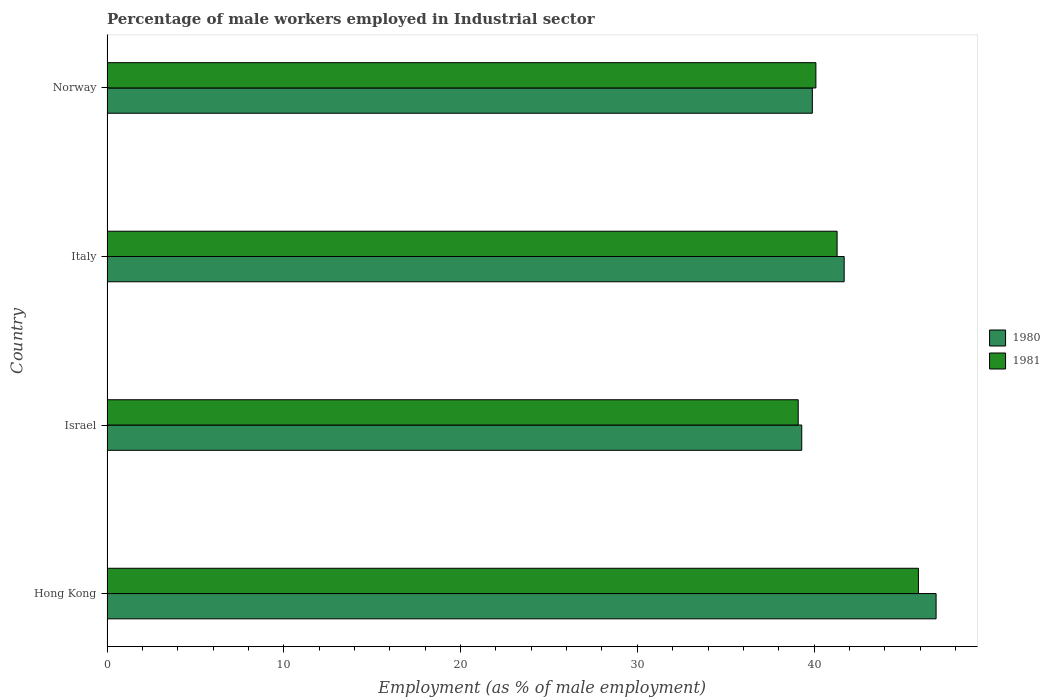How many bars are there on the 1st tick from the top?
Offer a terse response. 2. How many bars are there on the 3rd tick from the bottom?
Make the answer very short. 2. What is the percentage of male workers employed in Industrial sector in 1980 in Italy?
Give a very brief answer. 41.7. Across all countries, what is the maximum percentage of male workers employed in Industrial sector in 1980?
Offer a very short reply. 46.9. Across all countries, what is the minimum percentage of male workers employed in Industrial sector in 1981?
Provide a short and direct response. 39.1. In which country was the percentage of male workers employed in Industrial sector in 1981 maximum?
Keep it short and to the point. Hong Kong. What is the total percentage of male workers employed in Industrial sector in 1981 in the graph?
Provide a succinct answer. 166.4. What is the difference between the percentage of male workers employed in Industrial sector in 1980 in Hong Kong and that in Italy?
Keep it short and to the point. 5.2. What is the difference between the percentage of male workers employed in Industrial sector in 1981 in Israel and the percentage of male workers employed in Industrial sector in 1980 in Norway?
Your response must be concise. -0.8. What is the average percentage of male workers employed in Industrial sector in 1981 per country?
Provide a succinct answer. 41.6. What is the difference between the percentage of male workers employed in Industrial sector in 1981 and percentage of male workers employed in Industrial sector in 1980 in Norway?
Ensure brevity in your answer.  0.2. In how many countries, is the percentage of male workers employed in Industrial sector in 1980 greater than 24 %?
Keep it short and to the point. 4. What is the ratio of the percentage of male workers employed in Industrial sector in 1980 in Italy to that in Norway?
Give a very brief answer. 1.05. Is the percentage of male workers employed in Industrial sector in 1980 in Hong Kong less than that in Italy?
Your answer should be compact. No. Is the difference between the percentage of male workers employed in Industrial sector in 1981 in Italy and Norway greater than the difference between the percentage of male workers employed in Industrial sector in 1980 in Italy and Norway?
Keep it short and to the point. No. What is the difference between the highest and the second highest percentage of male workers employed in Industrial sector in 1980?
Provide a succinct answer. 5.2. What is the difference between the highest and the lowest percentage of male workers employed in Industrial sector in 1981?
Keep it short and to the point. 6.8. Is the sum of the percentage of male workers employed in Industrial sector in 1981 in Israel and Italy greater than the maximum percentage of male workers employed in Industrial sector in 1980 across all countries?
Provide a short and direct response. Yes. What does the 1st bar from the top in Italy represents?
Make the answer very short. 1981. How many bars are there?
Your answer should be compact. 8. How many countries are there in the graph?
Give a very brief answer. 4. What is the difference between two consecutive major ticks on the X-axis?
Make the answer very short. 10. Does the graph contain any zero values?
Keep it short and to the point. No. Does the graph contain grids?
Provide a succinct answer. No. Where does the legend appear in the graph?
Your answer should be compact. Center right. How are the legend labels stacked?
Offer a very short reply. Vertical. What is the title of the graph?
Your answer should be compact. Percentage of male workers employed in Industrial sector. What is the label or title of the X-axis?
Your answer should be compact. Employment (as % of male employment). What is the label or title of the Y-axis?
Offer a very short reply. Country. What is the Employment (as % of male employment) in 1980 in Hong Kong?
Keep it short and to the point. 46.9. What is the Employment (as % of male employment) of 1981 in Hong Kong?
Make the answer very short. 45.9. What is the Employment (as % of male employment) of 1980 in Israel?
Provide a succinct answer. 39.3. What is the Employment (as % of male employment) in 1981 in Israel?
Provide a succinct answer. 39.1. What is the Employment (as % of male employment) of 1980 in Italy?
Your answer should be very brief. 41.7. What is the Employment (as % of male employment) of 1981 in Italy?
Make the answer very short. 41.3. What is the Employment (as % of male employment) in 1980 in Norway?
Offer a very short reply. 39.9. What is the Employment (as % of male employment) of 1981 in Norway?
Your answer should be very brief. 40.1. Across all countries, what is the maximum Employment (as % of male employment) of 1980?
Provide a short and direct response. 46.9. Across all countries, what is the maximum Employment (as % of male employment) of 1981?
Your answer should be very brief. 45.9. Across all countries, what is the minimum Employment (as % of male employment) in 1980?
Keep it short and to the point. 39.3. Across all countries, what is the minimum Employment (as % of male employment) in 1981?
Ensure brevity in your answer.  39.1. What is the total Employment (as % of male employment) in 1980 in the graph?
Ensure brevity in your answer.  167.8. What is the total Employment (as % of male employment) of 1981 in the graph?
Provide a succinct answer. 166.4. What is the difference between the Employment (as % of male employment) of 1981 in Hong Kong and that in Italy?
Provide a succinct answer. 4.6. What is the difference between the Employment (as % of male employment) of 1981 in Hong Kong and that in Norway?
Make the answer very short. 5.8. What is the difference between the Employment (as % of male employment) of 1980 in Israel and that in Norway?
Provide a short and direct response. -0.6. What is the difference between the Employment (as % of male employment) in 1980 in Italy and that in Norway?
Your answer should be compact. 1.8. What is the difference between the Employment (as % of male employment) in 1980 in Hong Kong and the Employment (as % of male employment) in 1981 in Italy?
Offer a terse response. 5.6. What is the difference between the Employment (as % of male employment) in 1980 in Israel and the Employment (as % of male employment) in 1981 in Italy?
Provide a short and direct response. -2. What is the average Employment (as % of male employment) in 1980 per country?
Ensure brevity in your answer.  41.95. What is the average Employment (as % of male employment) of 1981 per country?
Give a very brief answer. 41.6. What is the difference between the Employment (as % of male employment) in 1980 and Employment (as % of male employment) in 1981 in Hong Kong?
Your answer should be very brief. 1. What is the difference between the Employment (as % of male employment) of 1980 and Employment (as % of male employment) of 1981 in Norway?
Provide a succinct answer. -0.2. What is the ratio of the Employment (as % of male employment) of 1980 in Hong Kong to that in Israel?
Ensure brevity in your answer.  1.19. What is the ratio of the Employment (as % of male employment) of 1981 in Hong Kong to that in Israel?
Keep it short and to the point. 1.17. What is the ratio of the Employment (as % of male employment) in 1980 in Hong Kong to that in Italy?
Offer a very short reply. 1.12. What is the ratio of the Employment (as % of male employment) of 1981 in Hong Kong to that in Italy?
Give a very brief answer. 1.11. What is the ratio of the Employment (as % of male employment) in 1980 in Hong Kong to that in Norway?
Give a very brief answer. 1.18. What is the ratio of the Employment (as % of male employment) in 1981 in Hong Kong to that in Norway?
Provide a succinct answer. 1.14. What is the ratio of the Employment (as % of male employment) of 1980 in Israel to that in Italy?
Provide a succinct answer. 0.94. What is the ratio of the Employment (as % of male employment) in 1981 in Israel to that in Italy?
Your answer should be compact. 0.95. What is the ratio of the Employment (as % of male employment) in 1981 in Israel to that in Norway?
Your response must be concise. 0.98. What is the ratio of the Employment (as % of male employment) of 1980 in Italy to that in Norway?
Offer a terse response. 1.05. What is the ratio of the Employment (as % of male employment) in 1981 in Italy to that in Norway?
Your answer should be compact. 1.03. What is the difference between the highest and the second highest Employment (as % of male employment) in 1981?
Your answer should be very brief. 4.6. What is the difference between the highest and the lowest Employment (as % of male employment) in 1980?
Ensure brevity in your answer.  7.6. 